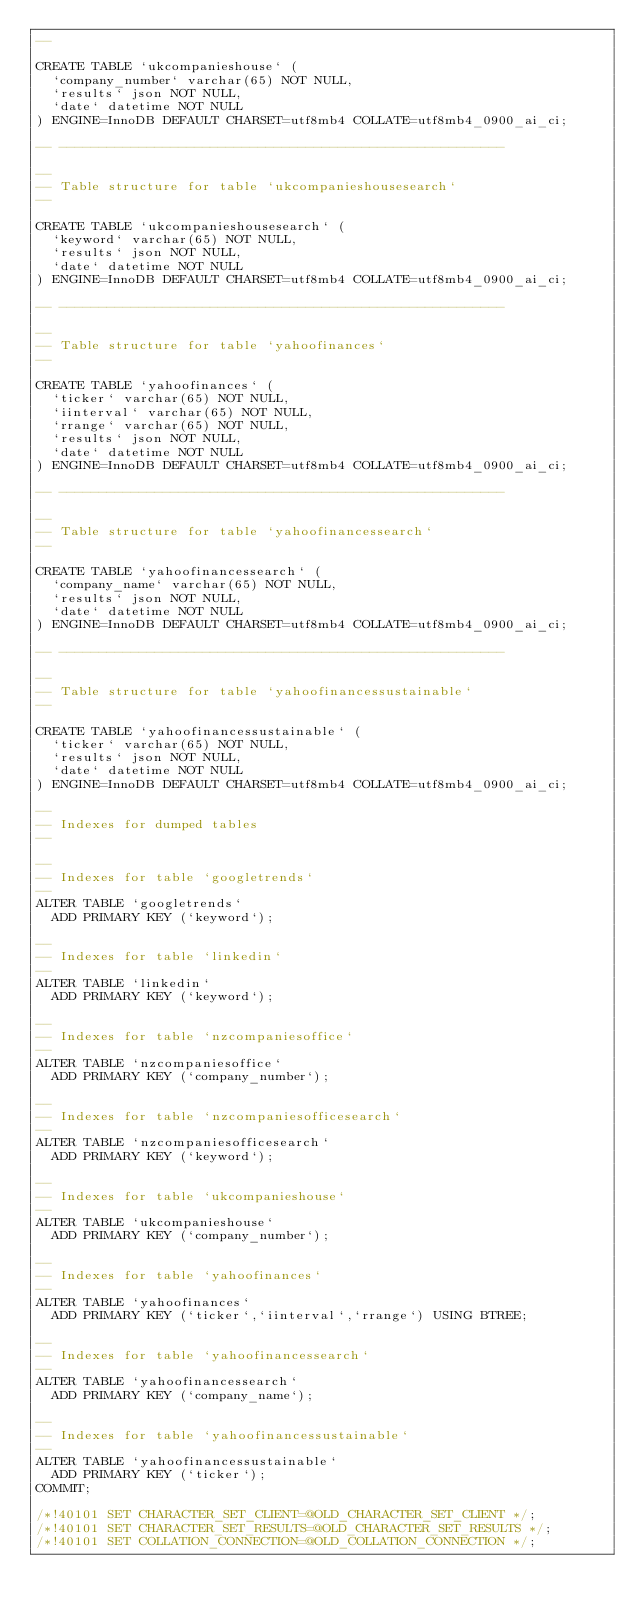<code> <loc_0><loc_0><loc_500><loc_500><_SQL_>--

CREATE TABLE `ukcompanieshouse` (
  `company_number` varchar(65) NOT NULL,
  `results` json NOT NULL,
  `date` datetime NOT NULL
) ENGINE=InnoDB DEFAULT CHARSET=utf8mb4 COLLATE=utf8mb4_0900_ai_ci;

-- --------------------------------------------------------

--
-- Table structure for table `ukcompanieshousesearch`
--

CREATE TABLE `ukcompanieshousesearch` (
  `keyword` varchar(65) NOT NULL,
  `results` json NOT NULL,
  `date` datetime NOT NULL
) ENGINE=InnoDB DEFAULT CHARSET=utf8mb4 COLLATE=utf8mb4_0900_ai_ci;

-- --------------------------------------------------------

--
-- Table structure for table `yahoofinances`
--

CREATE TABLE `yahoofinances` (
  `ticker` varchar(65) NOT NULL,
  `iinterval` varchar(65) NOT NULL,
  `rrange` varchar(65) NOT NULL,
  `results` json NOT NULL,
  `date` datetime NOT NULL
) ENGINE=InnoDB DEFAULT CHARSET=utf8mb4 COLLATE=utf8mb4_0900_ai_ci;

-- --------------------------------------------------------

--
-- Table structure for table `yahoofinancessearch`
--

CREATE TABLE `yahoofinancessearch` (
  `company_name` varchar(65) NOT NULL,
  `results` json NOT NULL,
  `date` datetime NOT NULL
) ENGINE=InnoDB DEFAULT CHARSET=utf8mb4 COLLATE=utf8mb4_0900_ai_ci;

-- --------------------------------------------------------

--
-- Table structure for table `yahoofinancessustainable`
--

CREATE TABLE `yahoofinancessustainable` (
  `ticker` varchar(65) NOT NULL,
  `results` json NOT NULL,
  `date` datetime NOT NULL
) ENGINE=InnoDB DEFAULT CHARSET=utf8mb4 COLLATE=utf8mb4_0900_ai_ci;

--
-- Indexes for dumped tables
--

--
-- Indexes for table `googletrends`
--
ALTER TABLE `googletrends`
  ADD PRIMARY KEY (`keyword`);

--
-- Indexes for table `linkedin`
--
ALTER TABLE `linkedin`
  ADD PRIMARY KEY (`keyword`);

--
-- Indexes for table `nzcompaniesoffice`
--
ALTER TABLE `nzcompaniesoffice`
  ADD PRIMARY KEY (`company_number`);

--
-- Indexes for table `nzcompaniesofficesearch`
--
ALTER TABLE `nzcompaniesofficesearch`
  ADD PRIMARY KEY (`keyword`);

--
-- Indexes for table `ukcompanieshouse`
--
ALTER TABLE `ukcompanieshouse`
  ADD PRIMARY KEY (`company_number`);

--
-- Indexes for table `yahoofinances`
--
ALTER TABLE `yahoofinances`
  ADD PRIMARY KEY (`ticker`,`iinterval`,`rrange`) USING BTREE;

--
-- Indexes for table `yahoofinancessearch`
--
ALTER TABLE `yahoofinancessearch`
  ADD PRIMARY KEY (`company_name`);

--
-- Indexes for table `yahoofinancessustainable`
--
ALTER TABLE `yahoofinancessustainable`
  ADD PRIMARY KEY (`ticker`);
COMMIT;

/*!40101 SET CHARACTER_SET_CLIENT=@OLD_CHARACTER_SET_CLIENT */;
/*!40101 SET CHARACTER_SET_RESULTS=@OLD_CHARACTER_SET_RESULTS */;
/*!40101 SET COLLATION_CONNECTION=@OLD_COLLATION_CONNECTION */;
</code> 